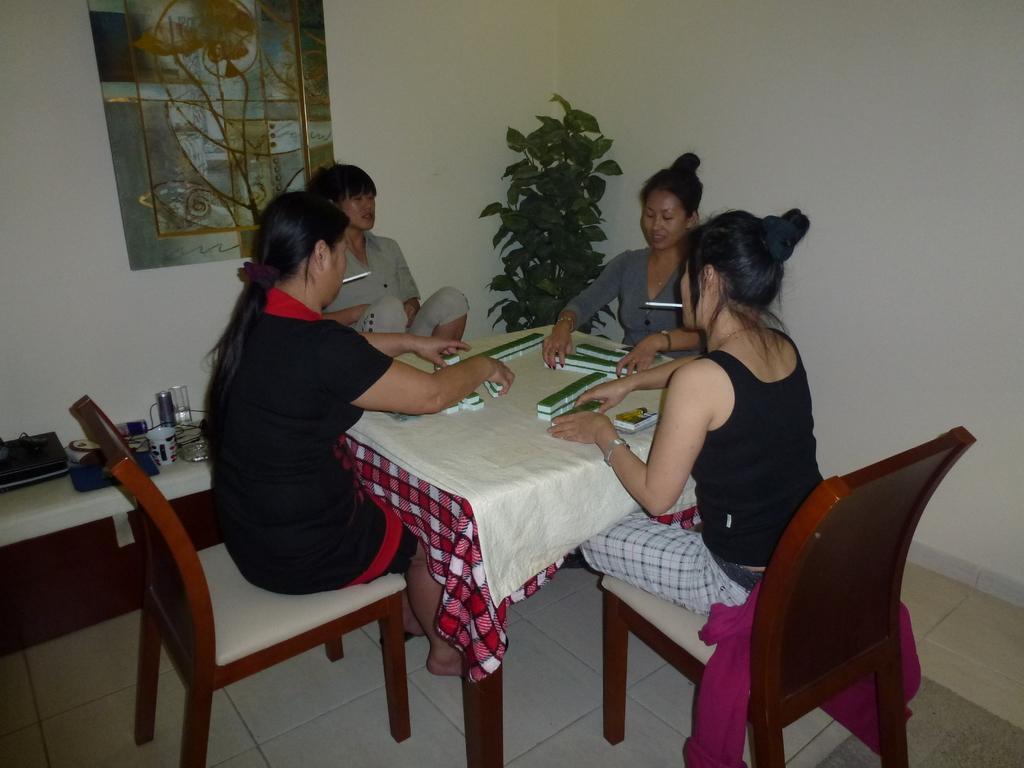Could you give a brief overview of what you see in this image? As we can see in the image there is a white color wall, photo frame, plant, few people sitting on chairs and a table. On table there are glasses. 